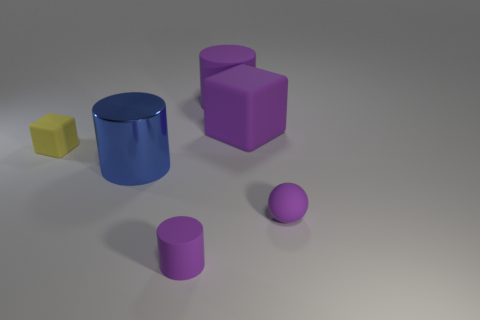Are there any other things that have the same material as the big blue object?
Make the answer very short. No. What is the material of the purple thing that is both in front of the big blue cylinder and right of the big purple cylinder?
Your response must be concise. Rubber. There is a matte cube behind the tiny yellow block; does it have the same color as the tiny matte cylinder?
Keep it short and to the point. Yes. There is a big rubber cylinder; is it the same color as the big rubber block right of the tiny purple cylinder?
Ensure brevity in your answer.  Yes. There is a blue object; are there any purple matte objects behind it?
Give a very brief answer. Yes. Are the sphere and the small cylinder made of the same material?
Provide a short and direct response. Yes. What material is the cylinder that is the same size as the yellow block?
Provide a succinct answer. Rubber. How many objects are either rubber cylinders behind the tiny ball or brown rubber cylinders?
Your response must be concise. 1. Are there the same number of blue things that are behind the yellow object and red metallic blocks?
Keep it short and to the point. Yes. Do the tiny rubber sphere and the large cube have the same color?
Make the answer very short. Yes. 